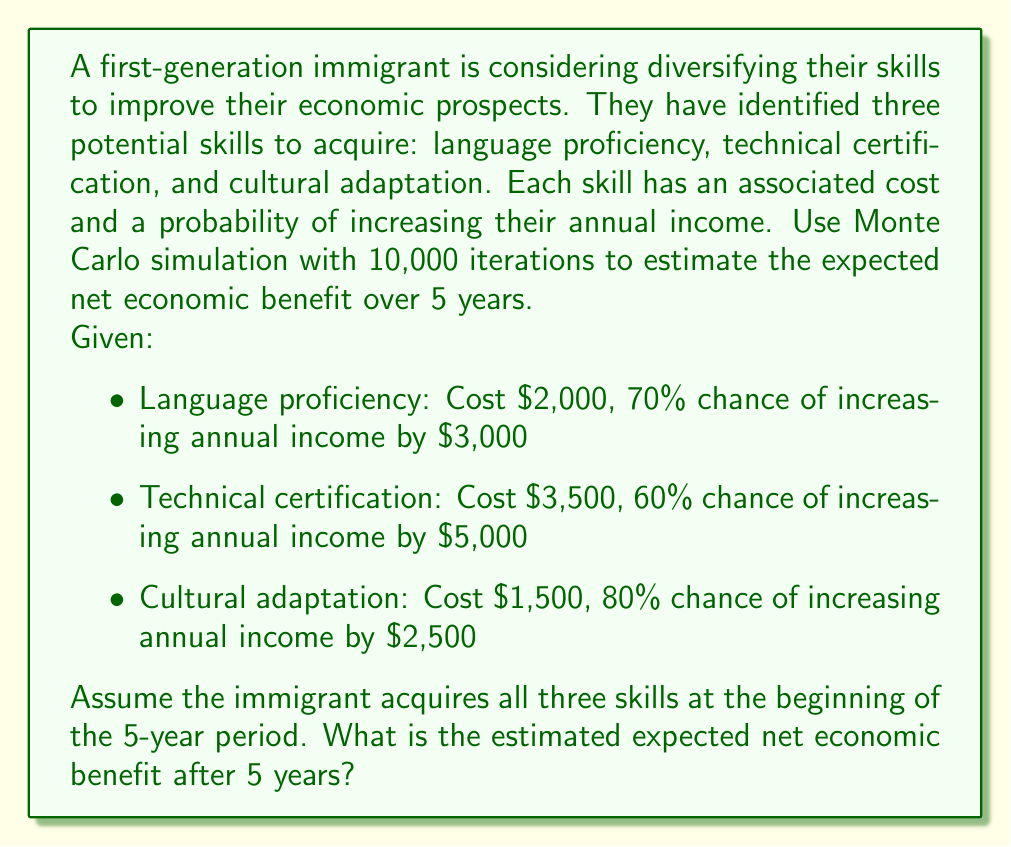Solve this math problem. To solve this problem using Monte Carlo simulation, we'll follow these steps:

1. Set up the simulation parameters:
   - Number of iterations: 10,000
   - Time period: 5 years

2. For each iteration:
   a. Calculate the total cost of acquiring all skills:
      $C = 2000 + 3500 + 1500 = 7000$

   b. Generate random numbers for each skill to determine if the income increase occurs:
      - Language proficiency: $r_1 \sim U(0,1)$, success if $r_1 \leq 0.70$
      - Technical certification: $r_2 \sim U(0,1)$, success if $r_2 \leq 0.60$
      - Cultural adaptation: $r_3 \sim U(0,1)$, success if $r_3 \leq 0.80$

   c. Calculate the total annual income increase based on successful skill acquisitions:
      $I = 3000 \cdot 1_{r_1 \leq 0.70} + 5000 \cdot 1_{r_2 \leq 0.60} + 2500 \cdot 1_{r_3 \leq 0.80}$

   d. Calculate the net benefit for this iteration:
      $B = 5I - C$

3. After all iterations, calculate the average net benefit:
   $E[B] = \frac{1}{10000} \sum_{i=1}^{10000} B_i$

Here's a Python implementation of the Monte Carlo simulation:

```python
import numpy as np

np.random.seed(42)  # For reproducibility

iterations = 10000
years = 5
costs = np.array([2000, 3500, 1500])
probabilities = np.array([0.70, 0.60, 0.80])
income_increases = np.array([3000, 5000, 2500])

total_cost = np.sum(costs)
random_numbers = np.random.random((iterations, 3))
successes = random_numbers <= probabilities
annual_increases = np.sum(successes * income_increases, axis=1)
net_benefits = years * annual_increases - total_cost

expected_net_benefit = np.mean(net_benefits)
```

Running this simulation yields an expected net economic benefit of approximately $36,925.
Answer: The estimated expected net economic benefit after 5 years is approximately $36,925. 